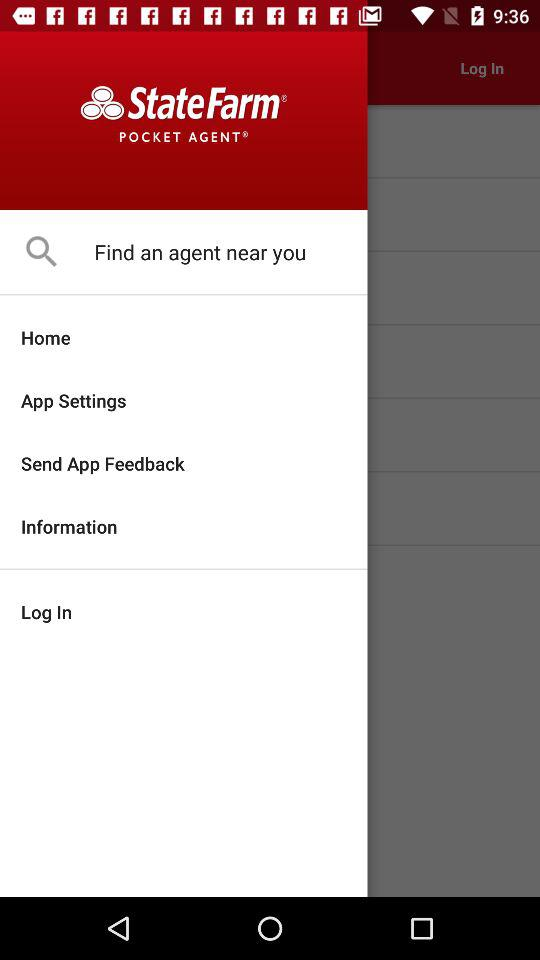What is the application name? The application name is "State Farm® POCKET AGENT®". 